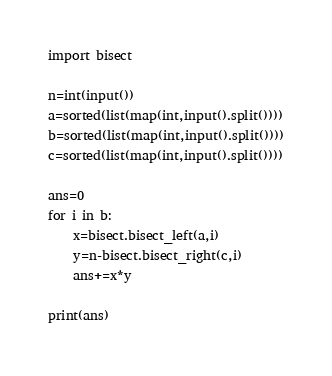<code> <loc_0><loc_0><loc_500><loc_500><_Python_>import bisect

n=int(input())
a=sorted(list(map(int,input().split())))
b=sorted(list(map(int,input().split())))
c=sorted(list(map(int,input().split())))

ans=0
for i in b:
    x=bisect.bisect_left(a,i)
    y=n-bisect.bisect_right(c,i)
    ans+=x*y

print(ans)</code> 